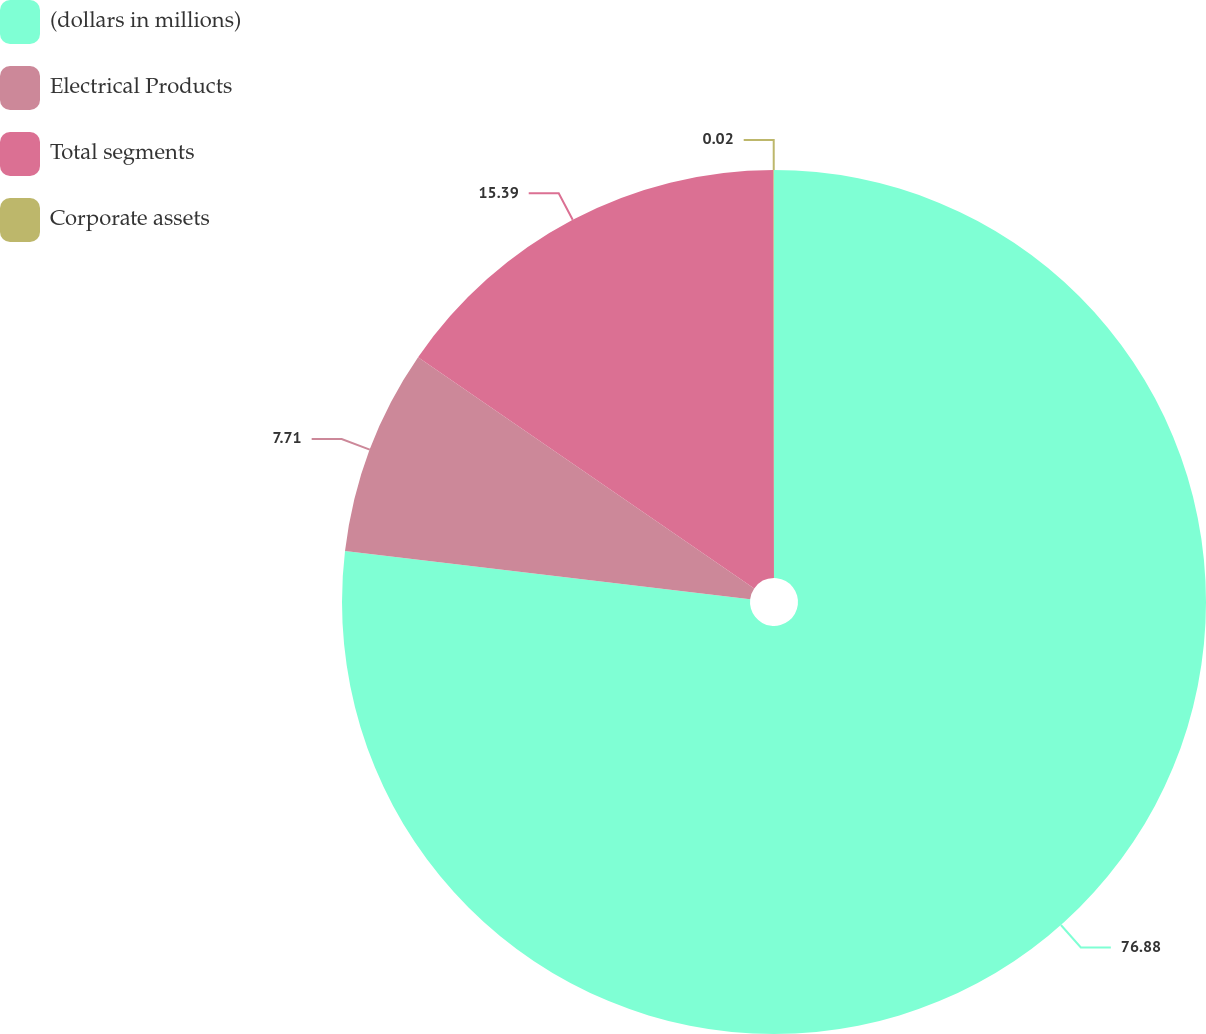<chart> <loc_0><loc_0><loc_500><loc_500><pie_chart><fcel>(dollars in millions)<fcel>Electrical Products<fcel>Total segments<fcel>Corporate assets<nl><fcel>76.88%<fcel>7.71%<fcel>15.39%<fcel>0.02%<nl></chart> 